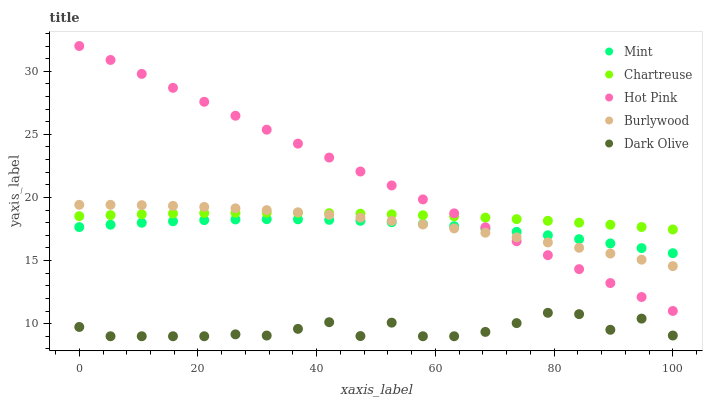Does Dark Olive have the minimum area under the curve?
Answer yes or no. Yes. Does Hot Pink have the maximum area under the curve?
Answer yes or no. Yes. Does Chartreuse have the minimum area under the curve?
Answer yes or no. No. Does Chartreuse have the maximum area under the curve?
Answer yes or no. No. Is Hot Pink the smoothest?
Answer yes or no. Yes. Is Dark Olive the roughest?
Answer yes or no. Yes. Is Chartreuse the smoothest?
Answer yes or no. No. Is Chartreuse the roughest?
Answer yes or no. No. Does Dark Olive have the lowest value?
Answer yes or no. Yes. Does Hot Pink have the lowest value?
Answer yes or no. No. Does Hot Pink have the highest value?
Answer yes or no. Yes. Does Chartreuse have the highest value?
Answer yes or no. No. Is Dark Olive less than Mint?
Answer yes or no. Yes. Is Chartreuse greater than Mint?
Answer yes or no. Yes. Does Burlywood intersect Mint?
Answer yes or no. Yes. Is Burlywood less than Mint?
Answer yes or no. No. Is Burlywood greater than Mint?
Answer yes or no. No. Does Dark Olive intersect Mint?
Answer yes or no. No. 